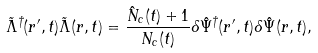Convert formula to latex. <formula><loc_0><loc_0><loc_500><loc_500>\tilde { \Lambda } ^ { \dagger } ( r ^ { \prime } , t ) \tilde { \Lambda } ( r , t ) = \frac { \hat { N } _ { c } ( t ) + 1 } { N _ { c } ( t ) } \delta \hat { \Psi } ^ { \dagger } ( r ^ { \prime } , t ) \delta \hat { \Psi } ( r , t ) ,</formula> 